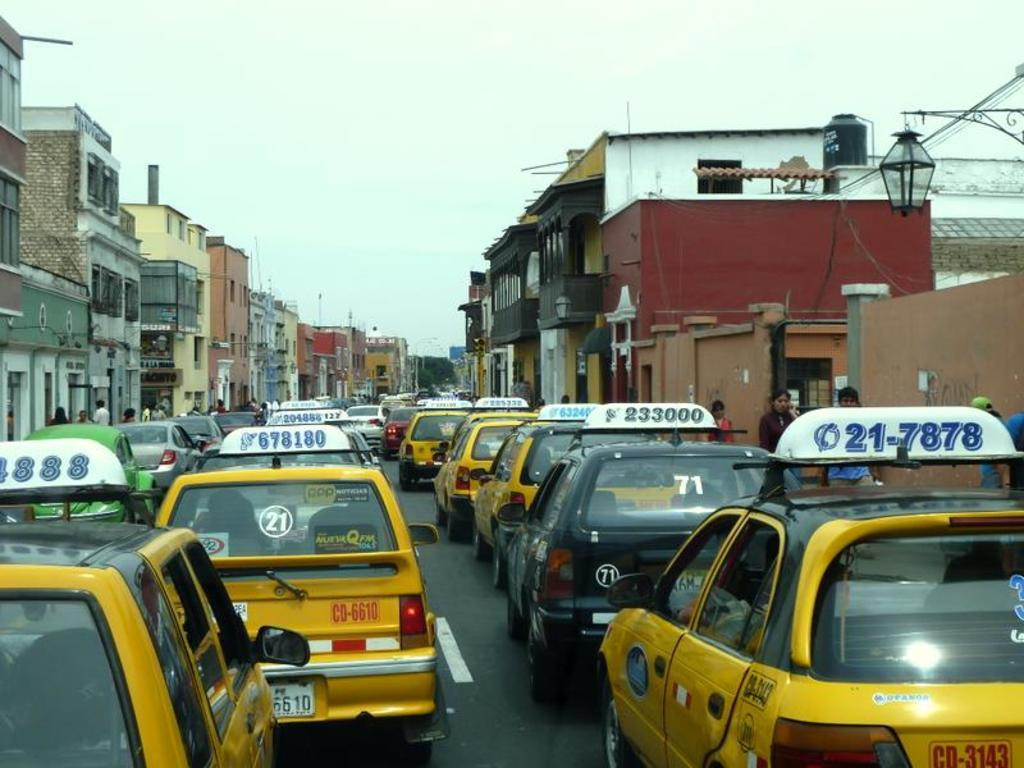What type of view is shown in the image? The image is an outside view. What can be seen on the road in the image? There are many cars on the road. What structures are visible on both sides of the road? There are buildings on both sides of the road. What is visible at the top of the image? The sky is visible at the top of the image. Where is the scarecrow standing in the image? There is no scarecrow present in the image. What type of tub is visible in the image? There is no tub present in the image. 